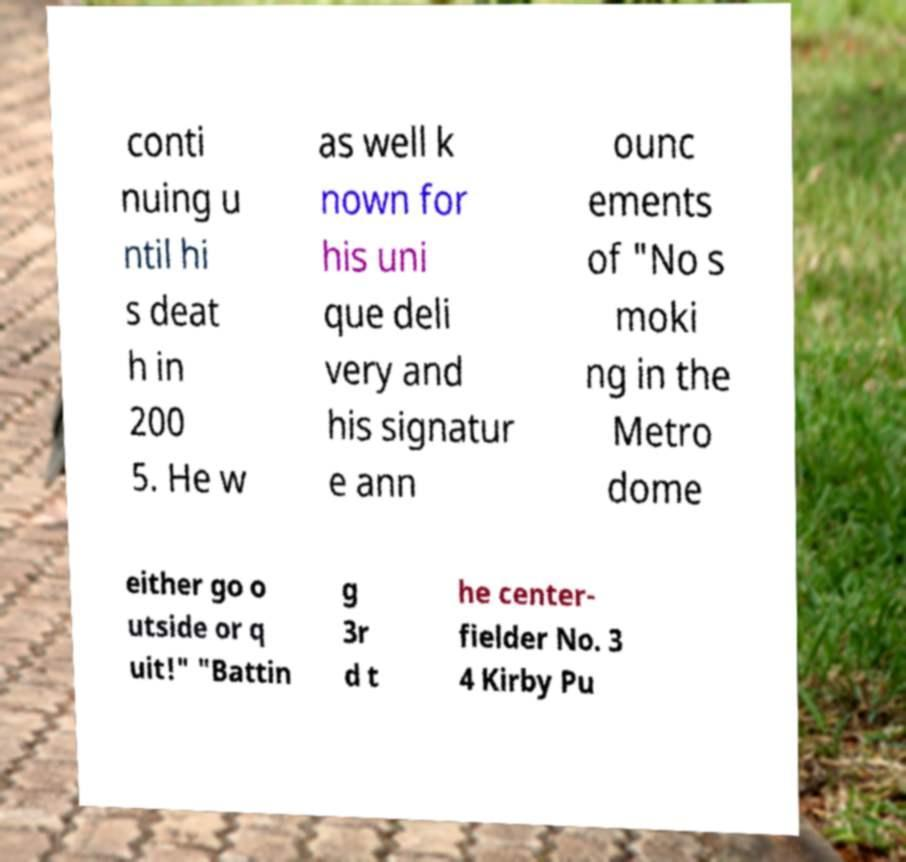There's text embedded in this image that I need extracted. Can you transcribe it verbatim? conti nuing u ntil hi s deat h in 200 5. He w as well k nown for his uni que deli very and his signatur e ann ounc ements of "No s moki ng in the Metro dome either go o utside or q uit!" "Battin g 3r d t he center- fielder No. 3 4 Kirby Pu 